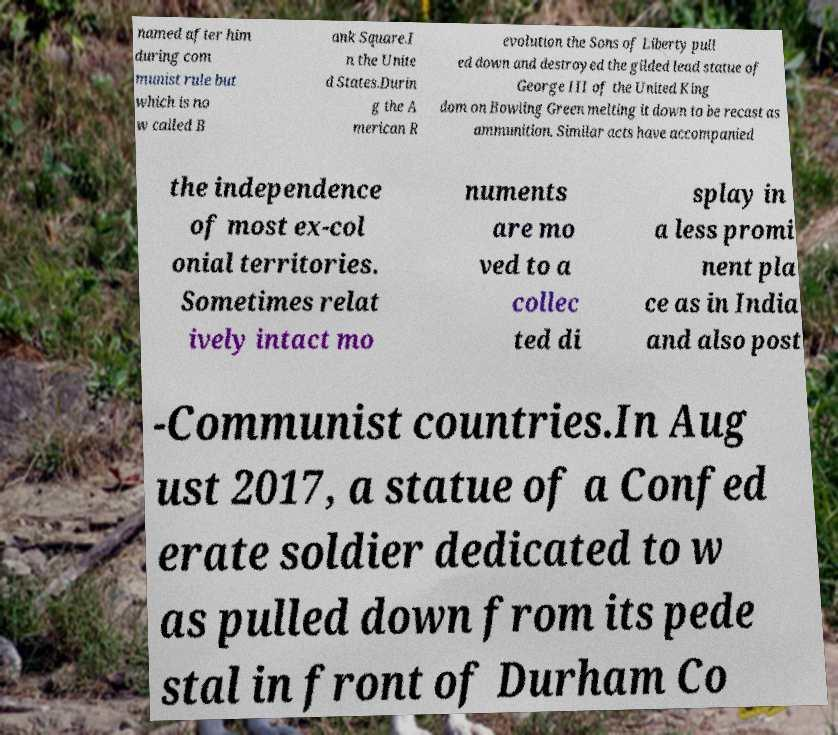Could you assist in decoding the text presented in this image and type it out clearly? named after him during com munist rule but which is no w called B ank Square.I n the Unite d States.Durin g the A merican R evolution the Sons of Liberty pull ed down and destroyed the gilded lead statue of George III of the United King dom on Bowling Green melting it down to be recast as ammunition. Similar acts have accompanied the independence of most ex-col onial territories. Sometimes relat ively intact mo numents are mo ved to a collec ted di splay in a less promi nent pla ce as in India and also post -Communist countries.In Aug ust 2017, a statue of a Confed erate soldier dedicated to w as pulled down from its pede stal in front of Durham Co 